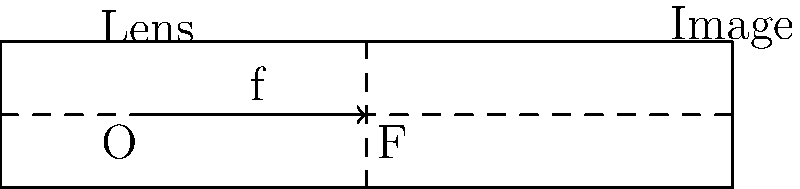In a medical imaging system, a lens is used to focus light onto a sensor. The distance from the optical center of the lens to the image sensor is 8 cm, and the image formed is 3 times larger than the object. Using the thin lens equation and magnification formula, calculate the focal length $f$ of the lens. Let's approach this step-by-step:

1) First, let's recall the thin lens equation:
   $$\frac{1}{f} = \frac{1}{d_o} + \frac{1}{d_i}$$
   where $f$ is the focal length, $d_o$ is the object distance, and $d_i$ is the image distance.

2) We're given that the image distance $d_i = 8$ cm.

3) We're also told that the image is 3 times larger than the object. This is the magnification $M$, which is given by:
   $$M = \frac{d_i}{d_o} = 3$$

4) From this, we can find $d_o$:
   $$d_o = \frac{d_i}{M} = \frac{8}{3} \approx 2.67 \text{ cm}$$

5) Now we have both $d_o$ and $d_i$. Let's substitute these into the thin lens equation:
   $$\frac{1}{f} = \frac{1}{2.67} + \frac{1}{8}$$

6) Simplifying:
   $$\frac{1}{f} = \frac{3}{8} + \frac{1}{8} = \frac{1}{2}$$

7) Therefore:
   $$f = 2 \text{ cm}$$
Answer: 2 cm 